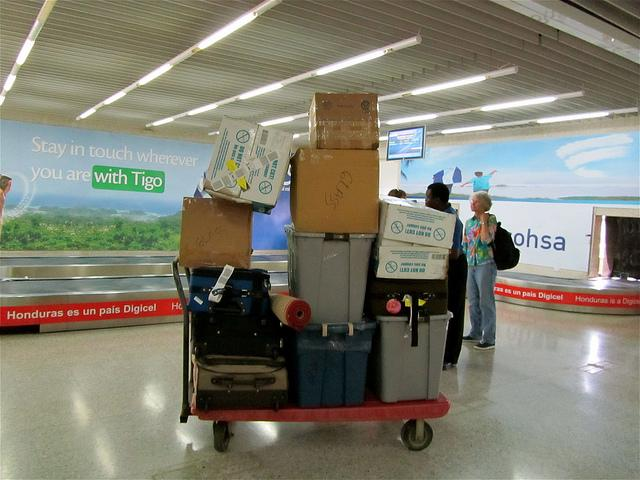What country is this venue situated in? honduras 